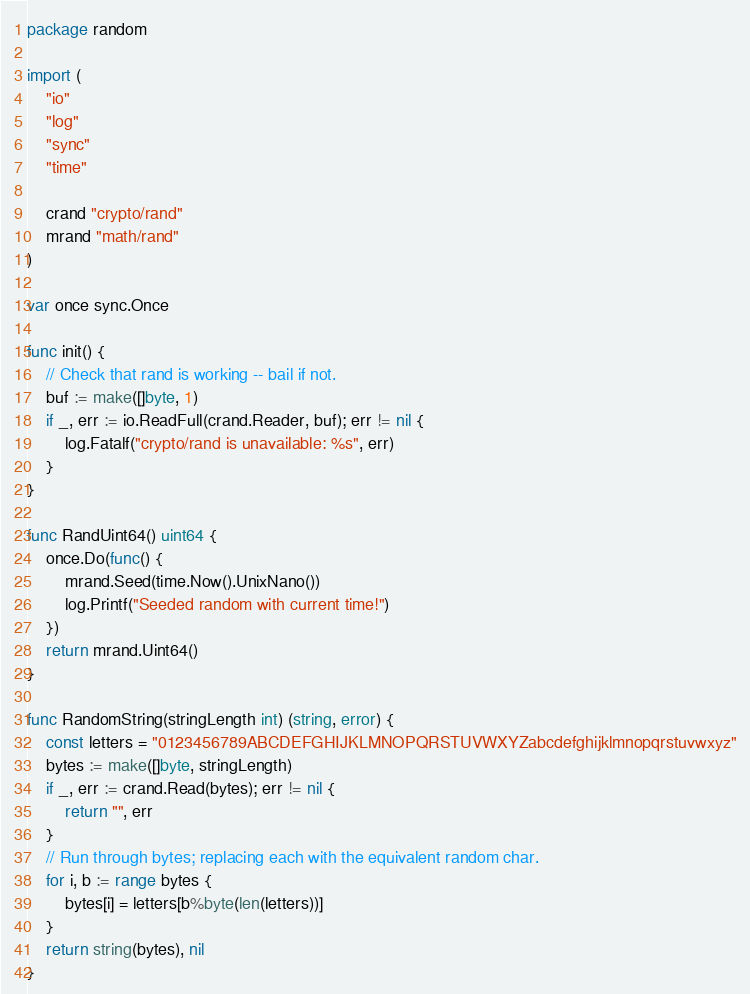Convert code to text. <code><loc_0><loc_0><loc_500><loc_500><_Go_>package random

import (
	"io"
	"log"
	"sync"
	"time"

	crand "crypto/rand"
	mrand "math/rand"
)

var once sync.Once

func init() {
	// Check that rand is working -- bail if not.
	buf := make([]byte, 1)
	if _, err := io.ReadFull(crand.Reader, buf); err != nil {
		log.Fatalf("crypto/rand is unavailable: %s", err)
	}
}

func RandUint64() uint64 {
	once.Do(func() {
		mrand.Seed(time.Now().UnixNano())
		log.Printf("Seeded random with current time!")
	})
	return mrand.Uint64()
}

func RandomString(stringLength int) (string, error) {
	const letters = "0123456789ABCDEFGHIJKLMNOPQRSTUVWXYZabcdefghijklmnopqrstuvwxyz"
	bytes := make([]byte, stringLength)
	if _, err := crand.Read(bytes); err != nil {
		return "", err
	}
	// Run through bytes; replacing each with the equivalent random char.
	for i, b := range bytes {
		bytes[i] = letters[b%byte(len(letters))]
	}
	return string(bytes), nil
}
</code> 